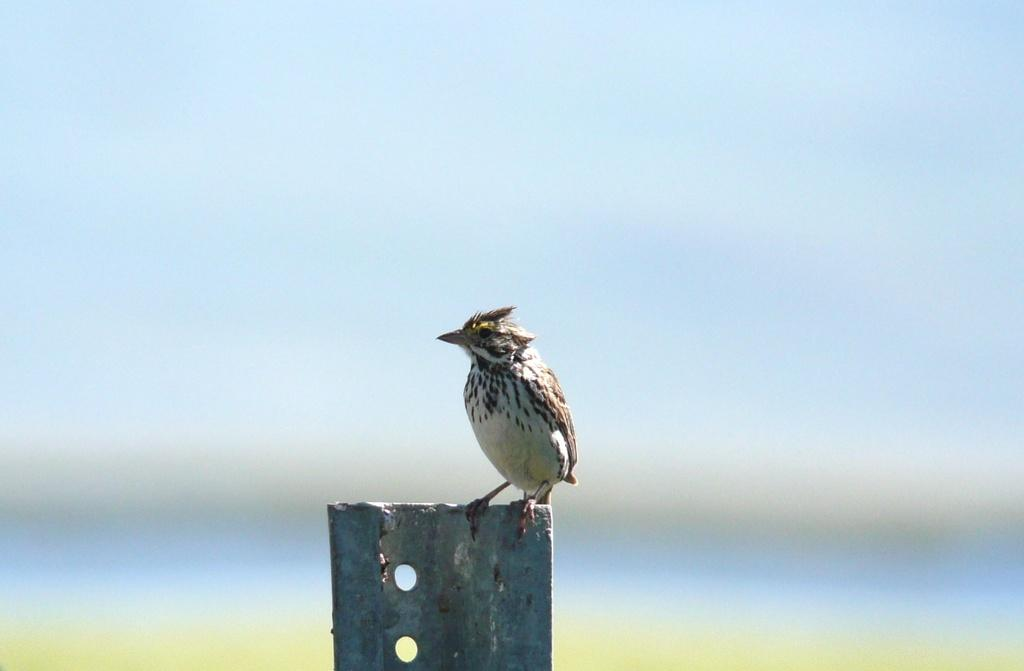What type of animal is in the image? There is a bird in the image. Can you describe the bird's coloring? The bird is cream, black, and grey in color. What is the bird standing on in the image? The bird is standing on a metal pole. How would you describe the background of the image? The background of the image is blurry. What colors are present in the background? The background colors are blue and green. What type of quince is being used as a prop in the image? There is no quince present in the image; it features a bird standing on a metal pole. 